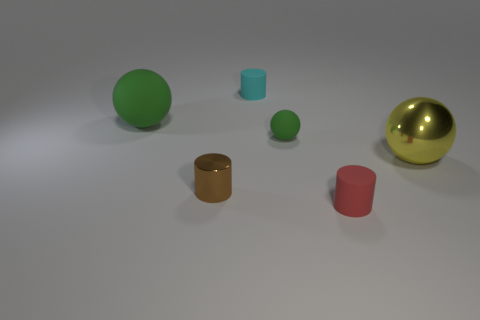There is a metal thing on the right side of the shiny cylinder; is its shape the same as the small metallic object?
Provide a succinct answer. No. Is the number of rubber spheres in front of the brown thing greater than the number of matte objects?
Your answer should be very brief. No. How many other brown cylinders are the same size as the brown cylinder?
Give a very brief answer. 0. What is the size of the other ball that is the same color as the small matte ball?
Your answer should be very brief. Large. What number of things are small objects or big balls left of the big metallic object?
Give a very brief answer. 5. What is the color of the small thing that is in front of the small sphere and to the right of the cyan cylinder?
Make the answer very short. Red. Do the brown shiny cylinder and the metal sphere have the same size?
Offer a very short reply. No. What color is the cylinder that is in front of the small brown cylinder?
Your answer should be very brief. Red. Are there any shiny balls of the same color as the big shiny object?
Your response must be concise. No. There is a matte ball that is the same size as the red thing; what color is it?
Your answer should be very brief. Green. 